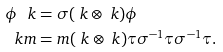<formula> <loc_0><loc_0><loc_500><loc_500>\phi \ k & = \sigma ( \ k \otimes \ k ) \phi \\ \ k m & = m ( \ k \otimes \ k ) \tau \sigma ^ { - 1 } \tau \sigma ^ { - 1 } \tau .</formula> 